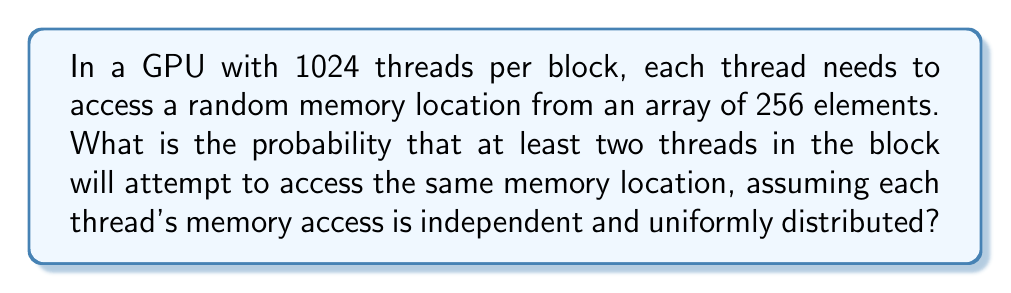Can you solve this math problem? To solve this problem, we can use the complement of the probability that all threads access different memory locations. This is a variation of the birthday problem.

Let's approach this step-by-step:

1) First, calculate the probability that all threads access different locations:

   $$P(\text{all different}) = \frac{256}{256} \cdot \frac{255}{256} \cdot \frac{254}{256} \cdot ... \cdot \frac{256 - 1023}{256}$$

2) This can be written as:

   $$P(\text{all different}) = \frac{256!}{256^{1024} \cdot (256-1024)!}$$

3) The probability of at least two threads accessing the same location is the complement of this:

   $$P(\text{at least one collision}) = 1 - P(\text{all different})$$

4) $$= 1 - \frac{256!}{256^{1024} \cdot (256-1024)!}$$

5) This expression is difficult to calculate directly due to the large numbers involved. We can use logarithms to simplify the computation:

   $$\log(P(\text{all different})) = \log(256!) - 1024\log(256) - \log((256-1024)!)$$

6) Using Stirling's approximation for the factorial terms and computing:

   $$\log(P(\text{all different})) \approx -3416.8$$

7) Therefore:

   $$P(\text{all different}) \approx e^{-3416.8} \approx 0$$

8) Thus:

   $$P(\text{at least one collision}) = 1 - P(\text{all different}) \approx 1 - 0 = 1$$
Answer: The probability that at least two threads in the block will attempt to access the same memory location is approximately 1 or 100%. 